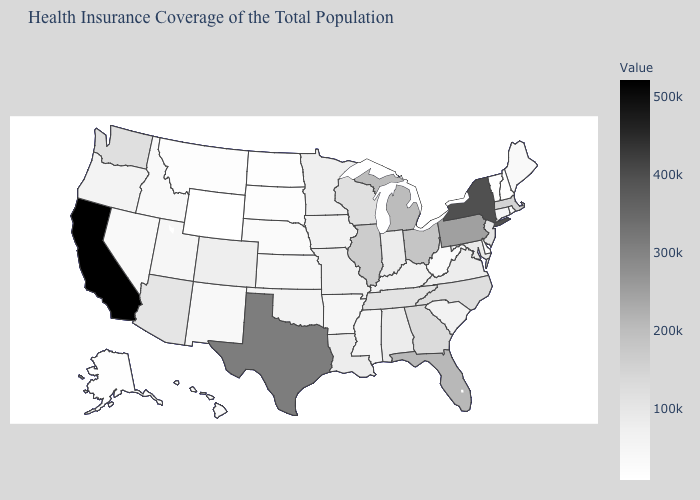Which states have the lowest value in the USA?
Write a very short answer. Wyoming. Does Minnesota have the lowest value in the MidWest?
Quick response, please. No. Is the legend a continuous bar?
Give a very brief answer. Yes. 